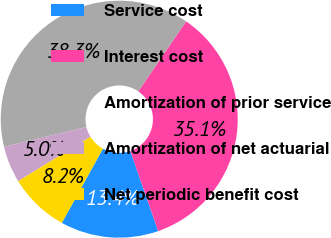Convert chart. <chart><loc_0><loc_0><loc_500><loc_500><pie_chart><fcel>Service cost<fcel>Interest cost<fcel>Amortization of prior service<fcel>Amortization of net actuarial<fcel>Net periodic benefit cost<nl><fcel>13.38%<fcel>35.12%<fcel>38.29%<fcel>5.02%<fcel>8.19%<nl></chart> 